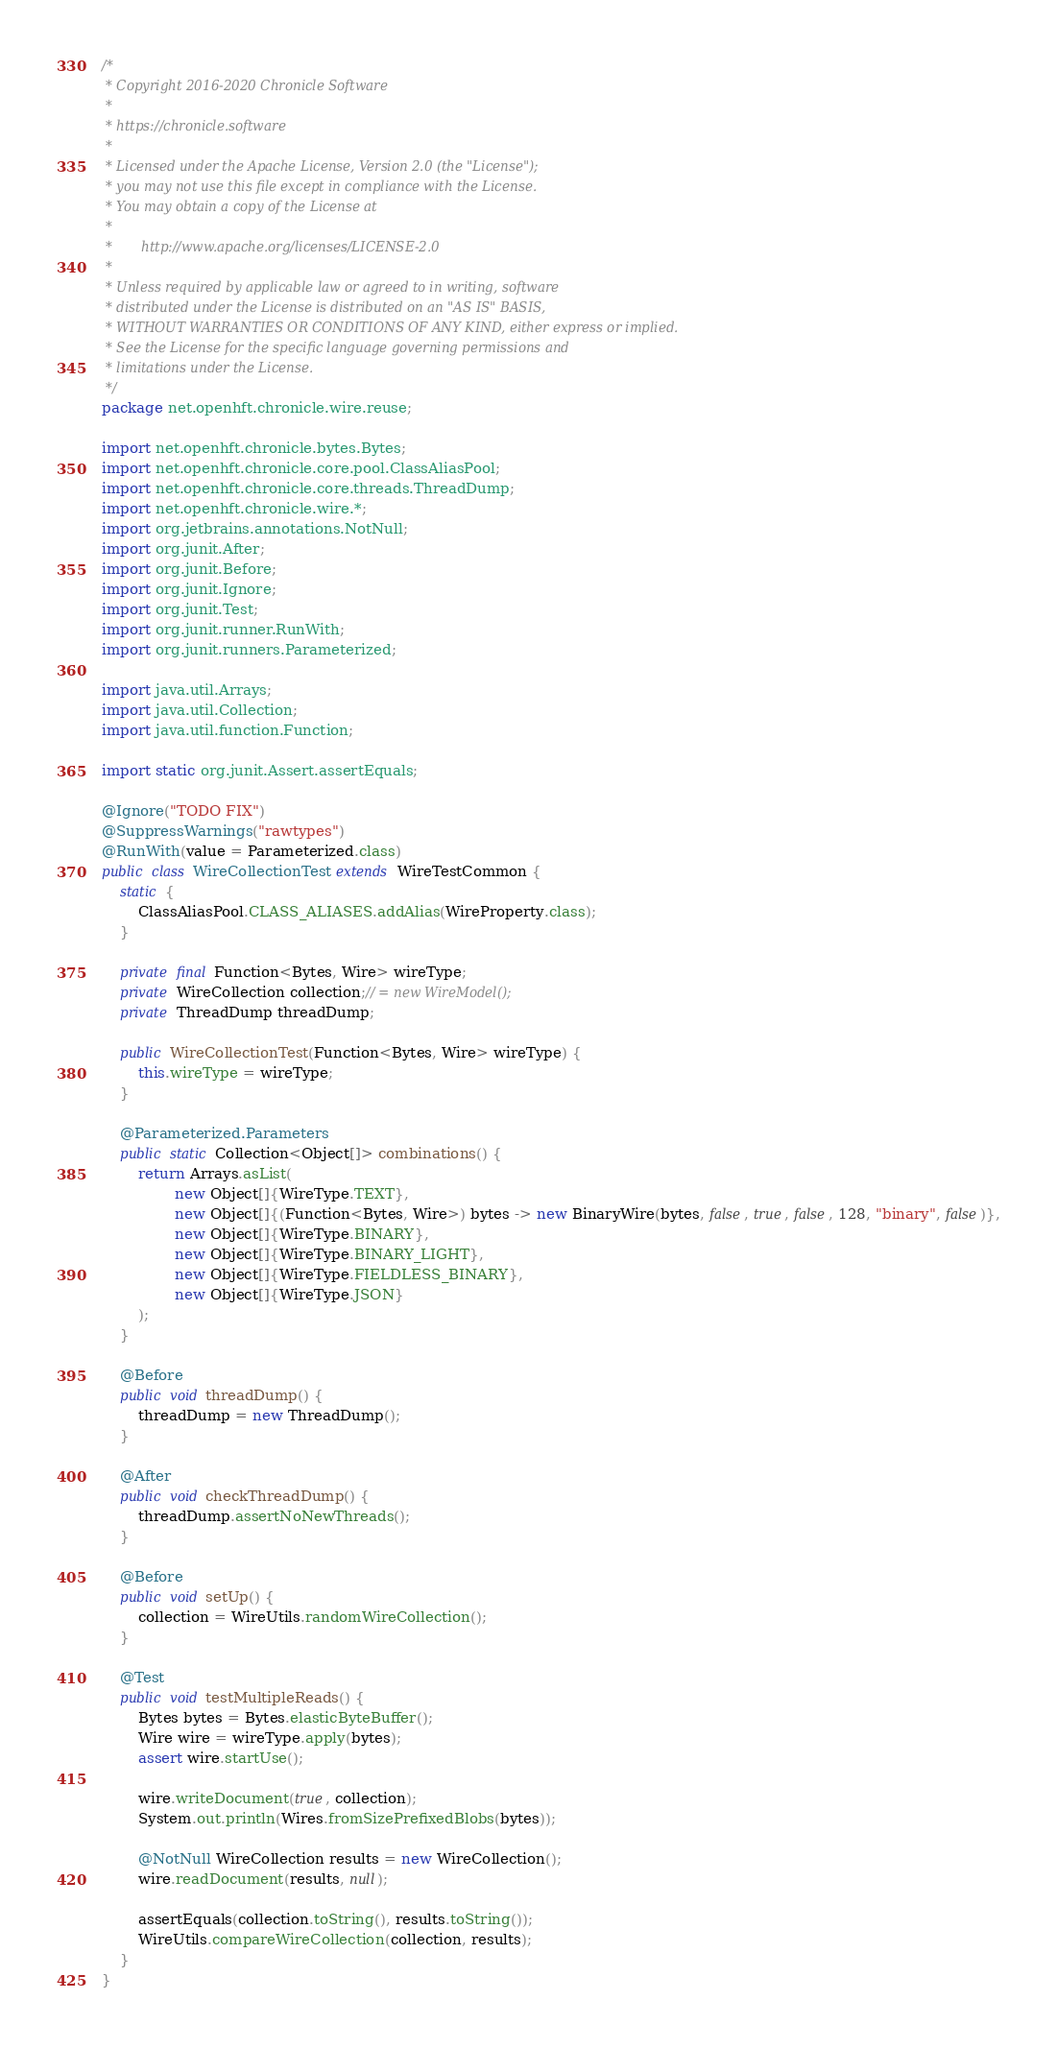<code> <loc_0><loc_0><loc_500><loc_500><_Java_>/*
 * Copyright 2016-2020 Chronicle Software
 *
 * https://chronicle.software
 *
 * Licensed under the Apache License, Version 2.0 (the "License");
 * you may not use this file except in compliance with the License.
 * You may obtain a copy of the License at
 *
 *       http://www.apache.org/licenses/LICENSE-2.0
 *
 * Unless required by applicable law or agreed to in writing, software
 * distributed under the License is distributed on an "AS IS" BASIS,
 * WITHOUT WARRANTIES OR CONDITIONS OF ANY KIND, either express or implied.
 * See the License for the specific language governing permissions and
 * limitations under the License.
 */
package net.openhft.chronicle.wire.reuse;

import net.openhft.chronicle.bytes.Bytes;
import net.openhft.chronicle.core.pool.ClassAliasPool;
import net.openhft.chronicle.core.threads.ThreadDump;
import net.openhft.chronicle.wire.*;
import org.jetbrains.annotations.NotNull;
import org.junit.After;
import org.junit.Before;
import org.junit.Ignore;
import org.junit.Test;
import org.junit.runner.RunWith;
import org.junit.runners.Parameterized;

import java.util.Arrays;
import java.util.Collection;
import java.util.function.Function;

import static org.junit.Assert.assertEquals;

@Ignore("TODO FIX")
@SuppressWarnings("rawtypes")
@RunWith(value = Parameterized.class)
public class WireCollectionTest extends WireTestCommon {
    static {
        ClassAliasPool.CLASS_ALIASES.addAlias(WireProperty.class);
    }

    private final Function<Bytes, Wire> wireType;
    private WireCollection collection;// = new WireModel();
    private ThreadDump threadDump;

    public WireCollectionTest(Function<Bytes, Wire> wireType) {
        this.wireType = wireType;
    }

    @Parameterized.Parameters
    public static Collection<Object[]> combinations() {
        return Arrays.asList(
                new Object[]{WireType.TEXT},
                new Object[]{(Function<Bytes, Wire>) bytes -> new BinaryWire(bytes, false, true, false, 128, "binary", false)},
                new Object[]{WireType.BINARY},
                new Object[]{WireType.BINARY_LIGHT},
                new Object[]{WireType.FIELDLESS_BINARY},
                new Object[]{WireType.JSON}
        );
    }

    @Before
    public void threadDump() {
        threadDump = new ThreadDump();
    }

    @After
    public void checkThreadDump() {
        threadDump.assertNoNewThreads();
    }

    @Before
    public void setUp() {
        collection = WireUtils.randomWireCollection();
    }

    @Test
    public void testMultipleReads() {
        Bytes bytes = Bytes.elasticByteBuffer();
        Wire wire = wireType.apply(bytes);
        assert wire.startUse();

        wire.writeDocument(true, collection);
        System.out.println(Wires.fromSizePrefixedBlobs(bytes));

        @NotNull WireCollection results = new WireCollection();
        wire.readDocument(results, null);

        assertEquals(collection.toString(), results.toString());
        WireUtils.compareWireCollection(collection, results);
    }
}
</code> 